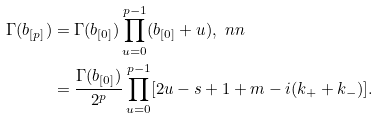<formula> <loc_0><loc_0><loc_500><loc_500>\Gamma ( b _ { [ p ] } ) & = \Gamma ( b _ { [ 0 ] } ) \prod _ { u = 0 } ^ { p - 1 } ( b _ { [ 0 ] } + u ) , \ n n \\ & = \frac { \Gamma ( b _ { [ 0 ] } ) } { 2 ^ { p } } \prod _ { u = 0 } ^ { p - 1 } [ 2 u - s + 1 + m - i ( k _ { + } + k _ { - } ) ] .</formula> 